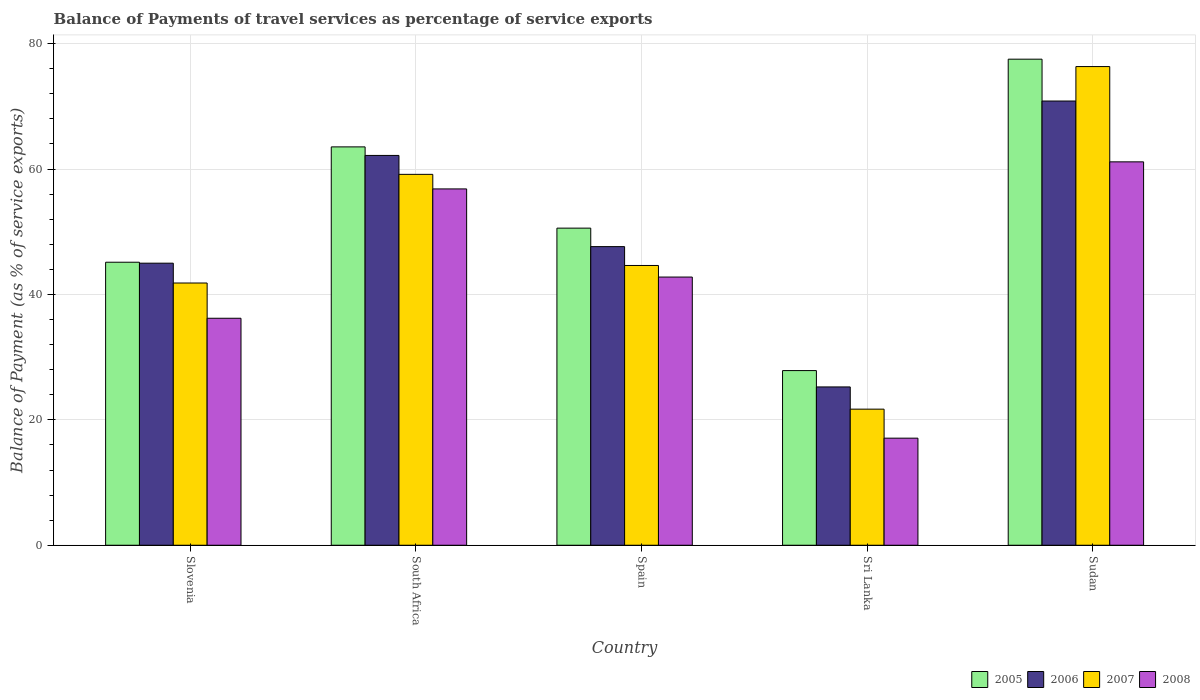How many different coloured bars are there?
Your response must be concise. 4. Are the number of bars per tick equal to the number of legend labels?
Provide a short and direct response. Yes. How many bars are there on the 3rd tick from the right?
Keep it short and to the point. 4. What is the label of the 2nd group of bars from the left?
Your answer should be compact. South Africa. In how many cases, is the number of bars for a given country not equal to the number of legend labels?
Ensure brevity in your answer.  0. What is the balance of payments of travel services in 2006 in South Africa?
Provide a succinct answer. 62.18. Across all countries, what is the maximum balance of payments of travel services in 2006?
Your answer should be very brief. 70.85. Across all countries, what is the minimum balance of payments of travel services in 2007?
Offer a terse response. 21.71. In which country was the balance of payments of travel services in 2005 maximum?
Provide a succinct answer. Sudan. In which country was the balance of payments of travel services in 2007 minimum?
Ensure brevity in your answer.  Sri Lanka. What is the total balance of payments of travel services in 2008 in the graph?
Your response must be concise. 214.05. What is the difference between the balance of payments of travel services in 2005 in South Africa and that in Spain?
Offer a terse response. 12.96. What is the difference between the balance of payments of travel services in 2005 in South Africa and the balance of payments of travel services in 2008 in Sudan?
Offer a very short reply. 2.39. What is the average balance of payments of travel services in 2005 per country?
Your answer should be compact. 52.93. What is the difference between the balance of payments of travel services of/in 2005 and balance of payments of travel services of/in 2007 in Sri Lanka?
Provide a succinct answer. 6.15. In how many countries, is the balance of payments of travel services in 2006 greater than 68 %?
Your answer should be very brief. 1. What is the ratio of the balance of payments of travel services in 2007 in Slovenia to that in Spain?
Your answer should be very brief. 0.94. What is the difference between the highest and the second highest balance of payments of travel services in 2008?
Your response must be concise. 14.06. What is the difference between the highest and the lowest balance of payments of travel services in 2006?
Offer a very short reply. 45.6. What does the 3rd bar from the left in Sudan represents?
Provide a succinct answer. 2007. How many bars are there?
Offer a terse response. 20. How many countries are there in the graph?
Offer a terse response. 5. Are the values on the major ticks of Y-axis written in scientific E-notation?
Give a very brief answer. No. Does the graph contain any zero values?
Give a very brief answer. No. Where does the legend appear in the graph?
Give a very brief answer. Bottom right. What is the title of the graph?
Ensure brevity in your answer.  Balance of Payments of travel services as percentage of service exports. What is the label or title of the X-axis?
Keep it short and to the point. Country. What is the label or title of the Y-axis?
Offer a very short reply. Balance of Payment (as % of service exports). What is the Balance of Payment (as % of service exports) in 2005 in Slovenia?
Offer a very short reply. 45.14. What is the Balance of Payment (as % of service exports) of 2006 in Slovenia?
Provide a short and direct response. 44.99. What is the Balance of Payment (as % of service exports) in 2007 in Slovenia?
Ensure brevity in your answer.  41.83. What is the Balance of Payment (as % of service exports) in 2008 in Slovenia?
Your response must be concise. 36.2. What is the Balance of Payment (as % of service exports) in 2005 in South Africa?
Ensure brevity in your answer.  63.54. What is the Balance of Payment (as % of service exports) in 2006 in South Africa?
Your answer should be very brief. 62.18. What is the Balance of Payment (as % of service exports) in 2007 in South Africa?
Give a very brief answer. 59.16. What is the Balance of Payment (as % of service exports) of 2008 in South Africa?
Give a very brief answer. 56.83. What is the Balance of Payment (as % of service exports) in 2005 in Spain?
Give a very brief answer. 50.58. What is the Balance of Payment (as % of service exports) of 2006 in Spain?
Your response must be concise. 47.63. What is the Balance of Payment (as % of service exports) in 2007 in Spain?
Offer a very short reply. 44.62. What is the Balance of Payment (as % of service exports) of 2008 in Spain?
Make the answer very short. 42.78. What is the Balance of Payment (as % of service exports) of 2005 in Sri Lanka?
Your response must be concise. 27.86. What is the Balance of Payment (as % of service exports) in 2006 in Sri Lanka?
Make the answer very short. 25.25. What is the Balance of Payment (as % of service exports) in 2007 in Sri Lanka?
Provide a short and direct response. 21.71. What is the Balance of Payment (as % of service exports) in 2008 in Sri Lanka?
Provide a short and direct response. 17.08. What is the Balance of Payment (as % of service exports) of 2005 in Sudan?
Your answer should be compact. 77.53. What is the Balance of Payment (as % of service exports) of 2006 in Sudan?
Your answer should be compact. 70.85. What is the Balance of Payment (as % of service exports) in 2007 in Sudan?
Ensure brevity in your answer.  76.35. What is the Balance of Payment (as % of service exports) in 2008 in Sudan?
Give a very brief answer. 61.15. Across all countries, what is the maximum Balance of Payment (as % of service exports) in 2005?
Your response must be concise. 77.53. Across all countries, what is the maximum Balance of Payment (as % of service exports) in 2006?
Provide a succinct answer. 70.85. Across all countries, what is the maximum Balance of Payment (as % of service exports) of 2007?
Ensure brevity in your answer.  76.35. Across all countries, what is the maximum Balance of Payment (as % of service exports) of 2008?
Provide a short and direct response. 61.15. Across all countries, what is the minimum Balance of Payment (as % of service exports) of 2005?
Offer a very short reply. 27.86. Across all countries, what is the minimum Balance of Payment (as % of service exports) in 2006?
Ensure brevity in your answer.  25.25. Across all countries, what is the minimum Balance of Payment (as % of service exports) in 2007?
Give a very brief answer. 21.71. Across all countries, what is the minimum Balance of Payment (as % of service exports) of 2008?
Provide a short and direct response. 17.08. What is the total Balance of Payment (as % of service exports) of 2005 in the graph?
Provide a succinct answer. 264.65. What is the total Balance of Payment (as % of service exports) of 2006 in the graph?
Your response must be concise. 250.9. What is the total Balance of Payment (as % of service exports) in 2007 in the graph?
Offer a very short reply. 243.66. What is the total Balance of Payment (as % of service exports) of 2008 in the graph?
Make the answer very short. 214.05. What is the difference between the Balance of Payment (as % of service exports) in 2005 in Slovenia and that in South Africa?
Your answer should be compact. -18.4. What is the difference between the Balance of Payment (as % of service exports) in 2006 in Slovenia and that in South Africa?
Your response must be concise. -17.19. What is the difference between the Balance of Payment (as % of service exports) of 2007 in Slovenia and that in South Africa?
Your answer should be compact. -17.33. What is the difference between the Balance of Payment (as % of service exports) in 2008 in Slovenia and that in South Africa?
Provide a short and direct response. -20.63. What is the difference between the Balance of Payment (as % of service exports) of 2005 in Slovenia and that in Spain?
Your answer should be compact. -5.44. What is the difference between the Balance of Payment (as % of service exports) of 2006 in Slovenia and that in Spain?
Provide a succinct answer. -2.64. What is the difference between the Balance of Payment (as % of service exports) of 2007 in Slovenia and that in Spain?
Make the answer very short. -2.8. What is the difference between the Balance of Payment (as % of service exports) in 2008 in Slovenia and that in Spain?
Keep it short and to the point. -6.57. What is the difference between the Balance of Payment (as % of service exports) in 2005 in Slovenia and that in Sri Lanka?
Make the answer very short. 17.28. What is the difference between the Balance of Payment (as % of service exports) of 2006 in Slovenia and that in Sri Lanka?
Your answer should be very brief. 19.74. What is the difference between the Balance of Payment (as % of service exports) in 2007 in Slovenia and that in Sri Lanka?
Your answer should be compact. 20.12. What is the difference between the Balance of Payment (as % of service exports) in 2008 in Slovenia and that in Sri Lanka?
Your response must be concise. 19.12. What is the difference between the Balance of Payment (as % of service exports) in 2005 in Slovenia and that in Sudan?
Offer a terse response. -32.39. What is the difference between the Balance of Payment (as % of service exports) in 2006 in Slovenia and that in Sudan?
Your response must be concise. -25.86. What is the difference between the Balance of Payment (as % of service exports) of 2007 in Slovenia and that in Sudan?
Provide a succinct answer. -34.52. What is the difference between the Balance of Payment (as % of service exports) in 2008 in Slovenia and that in Sudan?
Your answer should be very brief. -24.95. What is the difference between the Balance of Payment (as % of service exports) in 2005 in South Africa and that in Spain?
Make the answer very short. 12.96. What is the difference between the Balance of Payment (as % of service exports) of 2006 in South Africa and that in Spain?
Ensure brevity in your answer.  14.55. What is the difference between the Balance of Payment (as % of service exports) in 2007 in South Africa and that in Spain?
Ensure brevity in your answer.  14.53. What is the difference between the Balance of Payment (as % of service exports) in 2008 in South Africa and that in Spain?
Offer a terse response. 14.06. What is the difference between the Balance of Payment (as % of service exports) in 2005 in South Africa and that in Sri Lanka?
Provide a succinct answer. 35.68. What is the difference between the Balance of Payment (as % of service exports) of 2006 in South Africa and that in Sri Lanka?
Your answer should be very brief. 36.93. What is the difference between the Balance of Payment (as % of service exports) in 2007 in South Africa and that in Sri Lanka?
Ensure brevity in your answer.  37.45. What is the difference between the Balance of Payment (as % of service exports) in 2008 in South Africa and that in Sri Lanka?
Offer a terse response. 39.76. What is the difference between the Balance of Payment (as % of service exports) in 2005 in South Africa and that in Sudan?
Your answer should be compact. -13.99. What is the difference between the Balance of Payment (as % of service exports) in 2006 in South Africa and that in Sudan?
Make the answer very short. -8.68. What is the difference between the Balance of Payment (as % of service exports) of 2007 in South Africa and that in Sudan?
Offer a very short reply. -17.19. What is the difference between the Balance of Payment (as % of service exports) in 2008 in South Africa and that in Sudan?
Keep it short and to the point. -4.32. What is the difference between the Balance of Payment (as % of service exports) of 2005 in Spain and that in Sri Lanka?
Provide a short and direct response. 22.72. What is the difference between the Balance of Payment (as % of service exports) in 2006 in Spain and that in Sri Lanka?
Give a very brief answer. 22.38. What is the difference between the Balance of Payment (as % of service exports) in 2007 in Spain and that in Sri Lanka?
Make the answer very short. 22.92. What is the difference between the Balance of Payment (as % of service exports) in 2008 in Spain and that in Sri Lanka?
Your answer should be compact. 25.7. What is the difference between the Balance of Payment (as % of service exports) of 2005 in Spain and that in Sudan?
Your answer should be very brief. -26.95. What is the difference between the Balance of Payment (as % of service exports) of 2006 in Spain and that in Sudan?
Offer a very short reply. -23.22. What is the difference between the Balance of Payment (as % of service exports) in 2007 in Spain and that in Sudan?
Your response must be concise. -31.73. What is the difference between the Balance of Payment (as % of service exports) in 2008 in Spain and that in Sudan?
Provide a short and direct response. -18.38. What is the difference between the Balance of Payment (as % of service exports) in 2005 in Sri Lanka and that in Sudan?
Provide a succinct answer. -49.67. What is the difference between the Balance of Payment (as % of service exports) of 2006 in Sri Lanka and that in Sudan?
Give a very brief answer. -45.6. What is the difference between the Balance of Payment (as % of service exports) of 2007 in Sri Lanka and that in Sudan?
Ensure brevity in your answer.  -54.64. What is the difference between the Balance of Payment (as % of service exports) in 2008 in Sri Lanka and that in Sudan?
Your response must be concise. -44.07. What is the difference between the Balance of Payment (as % of service exports) in 2005 in Slovenia and the Balance of Payment (as % of service exports) in 2006 in South Africa?
Provide a short and direct response. -17.04. What is the difference between the Balance of Payment (as % of service exports) in 2005 in Slovenia and the Balance of Payment (as % of service exports) in 2007 in South Africa?
Provide a short and direct response. -14.02. What is the difference between the Balance of Payment (as % of service exports) of 2005 in Slovenia and the Balance of Payment (as % of service exports) of 2008 in South Africa?
Provide a short and direct response. -11.69. What is the difference between the Balance of Payment (as % of service exports) of 2006 in Slovenia and the Balance of Payment (as % of service exports) of 2007 in South Africa?
Give a very brief answer. -14.17. What is the difference between the Balance of Payment (as % of service exports) of 2006 in Slovenia and the Balance of Payment (as % of service exports) of 2008 in South Africa?
Provide a succinct answer. -11.84. What is the difference between the Balance of Payment (as % of service exports) of 2007 in Slovenia and the Balance of Payment (as % of service exports) of 2008 in South Africa?
Your response must be concise. -15.01. What is the difference between the Balance of Payment (as % of service exports) in 2005 in Slovenia and the Balance of Payment (as % of service exports) in 2006 in Spain?
Your answer should be very brief. -2.49. What is the difference between the Balance of Payment (as % of service exports) of 2005 in Slovenia and the Balance of Payment (as % of service exports) of 2007 in Spain?
Offer a very short reply. 0.52. What is the difference between the Balance of Payment (as % of service exports) of 2005 in Slovenia and the Balance of Payment (as % of service exports) of 2008 in Spain?
Provide a succinct answer. 2.37. What is the difference between the Balance of Payment (as % of service exports) of 2006 in Slovenia and the Balance of Payment (as % of service exports) of 2007 in Spain?
Offer a terse response. 0.37. What is the difference between the Balance of Payment (as % of service exports) of 2006 in Slovenia and the Balance of Payment (as % of service exports) of 2008 in Spain?
Provide a short and direct response. 2.21. What is the difference between the Balance of Payment (as % of service exports) in 2007 in Slovenia and the Balance of Payment (as % of service exports) in 2008 in Spain?
Keep it short and to the point. -0.95. What is the difference between the Balance of Payment (as % of service exports) of 2005 in Slovenia and the Balance of Payment (as % of service exports) of 2006 in Sri Lanka?
Provide a short and direct response. 19.89. What is the difference between the Balance of Payment (as % of service exports) of 2005 in Slovenia and the Balance of Payment (as % of service exports) of 2007 in Sri Lanka?
Give a very brief answer. 23.43. What is the difference between the Balance of Payment (as % of service exports) in 2005 in Slovenia and the Balance of Payment (as % of service exports) in 2008 in Sri Lanka?
Keep it short and to the point. 28.06. What is the difference between the Balance of Payment (as % of service exports) of 2006 in Slovenia and the Balance of Payment (as % of service exports) of 2007 in Sri Lanka?
Keep it short and to the point. 23.28. What is the difference between the Balance of Payment (as % of service exports) of 2006 in Slovenia and the Balance of Payment (as % of service exports) of 2008 in Sri Lanka?
Offer a very short reply. 27.91. What is the difference between the Balance of Payment (as % of service exports) in 2007 in Slovenia and the Balance of Payment (as % of service exports) in 2008 in Sri Lanka?
Your answer should be very brief. 24.75. What is the difference between the Balance of Payment (as % of service exports) in 2005 in Slovenia and the Balance of Payment (as % of service exports) in 2006 in Sudan?
Give a very brief answer. -25.71. What is the difference between the Balance of Payment (as % of service exports) of 2005 in Slovenia and the Balance of Payment (as % of service exports) of 2007 in Sudan?
Your answer should be very brief. -31.21. What is the difference between the Balance of Payment (as % of service exports) of 2005 in Slovenia and the Balance of Payment (as % of service exports) of 2008 in Sudan?
Make the answer very short. -16.01. What is the difference between the Balance of Payment (as % of service exports) in 2006 in Slovenia and the Balance of Payment (as % of service exports) in 2007 in Sudan?
Your response must be concise. -31.36. What is the difference between the Balance of Payment (as % of service exports) of 2006 in Slovenia and the Balance of Payment (as % of service exports) of 2008 in Sudan?
Provide a short and direct response. -16.16. What is the difference between the Balance of Payment (as % of service exports) of 2007 in Slovenia and the Balance of Payment (as % of service exports) of 2008 in Sudan?
Offer a very short reply. -19.33. What is the difference between the Balance of Payment (as % of service exports) of 2005 in South Africa and the Balance of Payment (as % of service exports) of 2006 in Spain?
Offer a terse response. 15.91. What is the difference between the Balance of Payment (as % of service exports) of 2005 in South Africa and the Balance of Payment (as % of service exports) of 2007 in Spain?
Ensure brevity in your answer.  18.92. What is the difference between the Balance of Payment (as % of service exports) of 2005 in South Africa and the Balance of Payment (as % of service exports) of 2008 in Spain?
Your response must be concise. 20.76. What is the difference between the Balance of Payment (as % of service exports) in 2006 in South Africa and the Balance of Payment (as % of service exports) in 2007 in Spain?
Ensure brevity in your answer.  17.55. What is the difference between the Balance of Payment (as % of service exports) of 2006 in South Africa and the Balance of Payment (as % of service exports) of 2008 in Spain?
Provide a succinct answer. 19.4. What is the difference between the Balance of Payment (as % of service exports) of 2007 in South Africa and the Balance of Payment (as % of service exports) of 2008 in Spain?
Offer a very short reply. 16.38. What is the difference between the Balance of Payment (as % of service exports) in 2005 in South Africa and the Balance of Payment (as % of service exports) in 2006 in Sri Lanka?
Offer a terse response. 38.29. What is the difference between the Balance of Payment (as % of service exports) of 2005 in South Africa and the Balance of Payment (as % of service exports) of 2007 in Sri Lanka?
Ensure brevity in your answer.  41.83. What is the difference between the Balance of Payment (as % of service exports) in 2005 in South Africa and the Balance of Payment (as % of service exports) in 2008 in Sri Lanka?
Offer a very short reply. 46.46. What is the difference between the Balance of Payment (as % of service exports) in 2006 in South Africa and the Balance of Payment (as % of service exports) in 2007 in Sri Lanka?
Offer a terse response. 40.47. What is the difference between the Balance of Payment (as % of service exports) of 2006 in South Africa and the Balance of Payment (as % of service exports) of 2008 in Sri Lanka?
Give a very brief answer. 45.1. What is the difference between the Balance of Payment (as % of service exports) in 2007 in South Africa and the Balance of Payment (as % of service exports) in 2008 in Sri Lanka?
Ensure brevity in your answer.  42.08. What is the difference between the Balance of Payment (as % of service exports) in 2005 in South Africa and the Balance of Payment (as % of service exports) in 2006 in Sudan?
Provide a succinct answer. -7.31. What is the difference between the Balance of Payment (as % of service exports) of 2005 in South Africa and the Balance of Payment (as % of service exports) of 2007 in Sudan?
Provide a succinct answer. -12.81. What is the difference between the Balance of Payment (as % of service exports) of 2005 in South Africa and the Balance of Payment (as % of service exports) of 2008 in Sudan?
Provide a short and direct response. 2.39. What is the difference between the Balance of Payment (as % of service exports) in 2006 in South Africa and the Balance of Payment (as % of service exports) in 2007 in Sudan?
Make the answer very short. -14.17. What is the difference between the Balance of Payment (as % of service exports) of 2006 in South Africa and the Balance of Payment (as % of service exports) of 2008 in Sudan?
Provide a short and direct response. 1.02. What is the difference between the Balance of Payment (as % of service exports) of 2007 in South Africa and the Balance of Payment (as % of service exports) of 2008 in Sudan?
Your answer should be compact. -2. What is the difference between the Balance of Payment (as % of service exports) of 2005 in Spain and the Balance of Payment (as % of service exports) of 2006 in Sri Lanka?
Your answer should be compact. 25.33. What is the difference between the Balance of Payment (as % of service exports) in 2005 in Spain and the Balance of Payment (as % of service exports) in 2007 in Sri Lanka?
Make the answer very short. 28.87. What is the difference between the Balance of Payment (as % of service exports) of 2005 in Spain and the Balance of Payment (as % of service exports) of 2008 in Sri Lanka?
Offer a very short reply. 33.5. What is the difference between the Balance of Payment (as % of service exports) in 2006 in Spain and the Balance of Payment (as % of service exports) in 2007 in Sri Lanka?
Your answer should be compact. 25.92. What is the difference between the Balance of Payment (as % of service exports) of 2006 in Spain and the Balance of Payment (as % of service exports) of 2008 in Sri Lanka?
Your answer should be very brief. 30.55. What is the difference between the Balance of Payment (as % of service exports) in 2007 in Spain and the Balance of Payment (as % of service exports) in 2008 in Sri Lanka?
Give a very brief answer. 27.54. What is the difference between the Balance of Payment (as % of service exports) of 2005 in Spain and the Balance of Payment (as % of service exports) of 2006 in Sudan?
Provide a succinct answer. -20.28. What is the difference between the Balance of Payment (as % of service exports) of 2005 in Spain and the Balance of Payment (as % of service exports) of 2007 in Sudan?
Offer a terse response. -25.77. What is the difference between the Balance of Payment (as % of service exports) in 2005 in Spain and the Balance of Payment (as % of service exports) in 2008 in Sudan?
Offer a very short reply. -10.57. What is the difference between the Balance of Payment (as % of service exports) of 2006 in Spain and the Balance of Payment (as % of service exports) of 2007 in Sudan?
Give a very brief answer. -28.72. What is the difference between the Balance of Payment (as % of service exports) of 2006 in Spain and the Balance of Payment (as % of service exports) of 2008 in Sudan?
Offer a very short reply. -13.52. What is the difference between the Balance of Payment (as % of service exports) of 2007 in Spain and the Balance of Payment (as % of service exports) of 2008 in Sudan?
Provide a short and direct response. -16.53. What is the difference between the Balance of Payment (as % of service exports) of 2005 in Sri Lanka and the Balance of Payment (as % of service exports) of 2006 in Sudan?
Your answer should be compact. -43. What is the difference between the Balance of Payment (as % of service exports) of 2005 in Sri Lanka and the Balance of Payment (as % of service exports) of 2007 in Sudan?
Provide a succinct answer. -48.49. What is the difference between the Balance of Payment (as % of service exports) of 2005 in Sri Lanka and the Balance of Payment (as % of service exports) of 2008 in Sudan?
Keep it short and to the point. -33.29. What is the difference between the Balance of Payment (as % of service exports) in 2006 in Sri Lanka and the Balance of Payment (as % of service exports) in 2007 in Sudan?
Offer a very short reply. -51.1. What is the difference between the Balance of Payment (as % of service exports) of 2006 in Sri Lanka and the Balance of Payment (as % of service exports) of 2008 in Sudan?
Keep it short and to the point. -35.9. What is the difference between the Balance of Payment (as % of service exports) of 2007 in Sri Lanka and the Balance of Payment (as % of service exports) of 2008 in Sudan?
Your answer should be very brief. -39.45. What is the average Balance of Payment (as % of service exports) in 2005 per country?
Make the answer very short. 52.93. What is the average Balance of Payment (as % of service exports) in 2006 per country?
Ensure brevity in your answer.  50.18. What is the average Balance of Payment (as % of service exports) of 2007 per country?
Offer a very short reply. 48.73. What is the average Balance of Payment (as % of service exports) of 2008 per country?
Offer a terse response. 42.81. What is the difference between the Balance of Payment (as % of service exports) of 2005 and Balance of Payment (as % of service exports) of 2006 in Slovenia?
Ensure brevity in your answer.  0.15. What is the difference between the Balance of Payment (as % of service exports) of 2005 and Balance of Payment (as % of service exports) of 2007 in Slovenia?
Offer a terse response. 3.31. What is the difference between the Balance of Payment (as % of service exports) in 2005 and Balance of Payment (as % of service exports) in 2008 in Slovenia?
Provide a short and direct response. 8.94. What is the difference between the Balance of Payment (as % of service exports) in 2006 and Balance of Payment (as % of service exports) in 2007 in Slovenia?
Offer a terse response. 3.16. What is the difference between the Balance of Payment (as % of service exports) of 2006 and Balance of Payment (as % of service exports) of 2008 in Slovenia?
Make the answer very short. 8.79. What is the difference between the Balance of Payment (as % of service exports) in 2007 and Balance of Payment (as % of service exports) in 2008 in Slovenia?
Offer a terse response. 5.62. What is the difference between the Balance of Payment (as % of service exports) in 2005 and Balance of Payment (as % of service exports) in 2006 in South Africa?
Ensure brevity in your answer.  1.36. What is the difference between the Balance of Payment (as % of service exports) of 2005 and Balance of Payment (as % of service exports) of 2007 in South Africa?
Ensure brevity in your answer.  4.38. What is the difference between the Balance of Payment (as % of service exports) in 2005 and Balance of Payment (as % of service exports) in 2008 in South Africa?
Your response must be concise. 6.71. What is the difference between the Balance of Payment (as % of service exports) in 2006 and Balance of Payment (as % of service exports) in 2007 in South Africa?
Ensure brevity in your answer.  3.02. What is the difference between the Balance of Payment (as % of service exports) of 2006 and Balance of Payment (as % of service exports) of 2008 in South Africa?
Make the answer very short. 5.34. What is the difference between the Balance of Payment (as % of service exports) of 2007 and Balance of Payment (as % of service exports) of 2008 in South Africa?
Ensure brevity in your answer.  2.32. What is the difference between the Balance of Payment (as % of service exports) in 2005 and Balance of Payment (as % of service exports) in 2006 in Spain?
Your answer should be very brief. 2.95. What is the difference between the Balance of Payment (as % of service exports) of 2005 and Balance of Payment (as % of service exports) of 2007 in Spain?
Offer a terse response. 5.96. What is the difference between the Balance of Payment (as % of service exports) in 2005 and Balance of Payment (as % of service exports) in 2008 in Spain?
Make the answer very short. 7.8. What is the difference between the Balance of Payment (as % of service exports) of 2006 and Balance of Payment (as % of service exports) of 2007 in Spain?
Provide a succinct answer. 3.01. What is the difference between the Balance of Payment (as % of service exports) in 2006 and Balance of Payment (as % of service exports) in 2008 in Spain?
Offer a terse response. 4.86. What is the difference between the Balance of Payment (as % of service exports) of 2007 and Balance of Payment (as % of service exports) of 2008 in Spain?
Make the answer very short. 1.85. What is the difference between the Balance of Payment (as % of service exports) in 2005 and Balance of Payment (as % of service exports) in 2006 in Sri Lanka?
Offer a very short reply. 2.61. What is the difference between the Balance of Payment (as % of service exports) of 2005 and Balance of Payment (as % of service exports) of 2007 in Sri Lanka?
Provide a short and direct response. 6.15. What is the difference between the Balance of Payment (as % of service exports) in 2005 and Balance of Payment (as % of service exports) in 2008 in Sri Lanka?
Your response must be concise. 10.78. What is the difference between the Balance of Payment (as % of service exports) of 2006 and Balance of Payment (as % of service exports) of 2007 in Sri Lanka?
Keep it short and to the point. 3.54. What is the difference between the Balance of Payment (as % of service exports) in 2006 and Balance of Payment (as % of service exports) in 2008 in Sri Lanka?
Offer a terse response. 8.17. What is the difference between the Balance of Payment (as % of service exports) in 2007 and Balance of Payment (as % of service exports) in 2008 in Sri Lanka?
Offer a terse response. 4.63. What is the difference between the Balance of Payment (as % of service exports) in 2005 and Balance of Payment (as % of service exports) in 2006 in Sudan?
Provide a short and direct response. 6.67. What is the difference between the Balance of Payment (as % of service exports) of 2005 and Balance of Payment (as % of service exports) of 2007 in Sudan?
Provide a short and direct response. 1.18. What is the difference between the Balance of Payment (as % of service exports) of 2005 and Balance of Payment (as % of service exports) of 2008 in Sudan?
Provide a short and direct response. 16.38. What is the difference between the Balance of Payment (as % of service exports) of 2006 and Balance of Payment (as % of service exports) of 2007 in Sudan?
Provide a succinct answer. -5.5. What is the difference between the Balance of Payment (as % of service exports) of 2006 and Balance of Payment (as % of service exports) of 2008 in Sudan?
Ensure brevity in your answer.  9.7. What is the difference between the Balance of Payment (as % of service exports) in 2007 and Balance of Payment (as % of service exports) in 2008 in Sudan?
Offer a terse response. 15.2. What is the ratio of the Balance of Payment (as % of service exports) in 2005 in Slovenia to that in South Africa?
Provide a short and direct response. 0.71. What is the ratio of the Balance of Payment (as % of service exports) of 2006 in Slovenia to that in South Africa?
Provide a short and direct response. 0.72. What is the ratio of the Balance of Payment (as % of service exports) in 2007 in Slovenia to that in South Africa?
Offer a very short reply. 0.71. What is the ratio of the Balance of Payment (as % of service exports) of 2008 in Slovenia to that in South Africa?
Offer a very short reply. 0.64. What is the ratio of the Balance of Payment (as % of service exports) of 2005 in Slovenia to that in Spain?
Your response must be concise. 0.89. What is the ratio of the Balance of Payment (as % of service exports) of 2006 in Slovenia to that in Spain?
Your answer should be very brief. 0.94. What is the ratio of the Balance of Payment (as % of service exports) in 2007 in Slovenia to that in Spain?
Offer a very short reply. 0.94. What is the ratio of the Balance of Payment (as % of service exports) of 2008 in Slovenia to that in Spain?
Keep it short and to the point. 0.85. What is the ratio of the Balance of Payment (as % of service exports) in 2005 in Slovenia to that in Sri Lanka?
Offer a terse response. 1.62. What is the ratio of the Balance of Payment (as % of service exports) in 2006 in Slovenia to that in Sri Lanka?
Keep it short and to the point. 1.78. What is the ratio of the Balance of Payment (as % of service exports) of 2007 in Slovenia to that in Sri Lanka?
Provide a succinct answer. 1.93. What is the ratio of the Balance of Payment (as % of service exports) in 2008 in Slovenia to that in Sri Lanka?
Your answer should be compact. 2.12. What is the ratio of the Balance of Payment (as % of service exports) in 2005 in Slovenia to that in Sudan?
Your answer should be compact. 0.58. What is the ratio of the Balance of Payment (as % of service exports) of 2006 in Slovenia to that in Sudan?
Offer a very short reply. 0.64. What is the ratio of the Balance of Payment (as % of service exports) in 2007 in Slovenia to that in Sudan?
Keep it short and to the point. 0.55. What is the ratio of the Balance of Payment (as % of service exports) of 2008 in Slovenia to that in Sudan?
Your response must be concise. 0.59. What is the ratio of the Balance of Payment (as % of service exports) in 2005 in South Africa to that in Spain?
Keep it short and to the point. 1.26. What is the ratio of the Balance of Payment (as % of service exports) in 2006 in South Africa to that in Spain?
Offer a terse response. 1.31. What is the ratio of the Balance of Payment (as % of service exports) of 2007 in South Africa to that in Spain?
Ensure brevity in your answer.  1.33. What is the ratio of the Balance of Payment (as % of service exports) in 2008 in South Africa to that in Spain?
Your response must be concise. 1.33. What is the ratio of the Balance of Payment (as % of service exports) in 2005 in South Africa to that in Sri Lanka?
Ensure brevity in your answer.  2.28. What is the ratio of the Balance of Payment (as % of service exports) in 2006 in South Africa to that in Sri Lanka?
Your response must be concise. 2.46. What is the ratio of the Balance of Payment (as % of service exports) of 2007 in South Africa to that in Sri Lanka?
Ensure brevity in your answer.  2.73. What is the ratio of the Balance of Payment (as % of service exports) of 2008 in South Africa to that in Sri Lanka?
Offer a terse response. 3.33. What is the ratio of the Balance of Payment (as % of service exports) of 2005 in South Africa to that in Sudan?
Give a very brief answer. 0.82. What is the ratio of the Balance of Payment (as % of service exports) in 2006 in South Africa to that in Sudan?
Keep it short and to the point. 0.88. What is the ratio of the Balance of Payment (as % of service exports) in 2007 in South Africa to that in Sudan?
Ensure brevity in your answer.  0.77. What is the ratio of the Balance of Payment (as % of service exports) of 2008 in South Africa to that in Sudan?
Give a very brief answer. 0.93. What is the ratio of the Balance of Payment (as % of service exports) in 2005 in Spain to that in Sri Lanka?
Ensure brevity in your answer.  1.82. What is the ratio of the Balance of Payment (as % of service exports) in 2006 in Spain to that in Sri Lanka?
Give a very brief answer. 1.89. What is the ratio of the Balance of Payment (as % of service exports) of 2007 in Spain to that in Sri Lanka?
Offer a very short reply. 2.06. What is the ratio of the Balance of Payment (as % of service exports) in 2008 in Spain to that in Sri Lanka?
Give a very brief answer. 2.5. What is the ratio of the Balance of Payment (as % of service exports) in 2005 in Spain to that in Sudan?
Provide a succinct answer. 0.65. What is the ratio of the Balance of Payment (as % of service exports) of 2006 in Spain to that in Sudan?
Your answer should be compact. 0.67. What is the ratio of the Balance of Payment (as % of service exports) of 2007 in Spain to that in Sudan?
Give a very brief answer. 0.58. What is the ratio of the Balance of Payment (as % of service exports) of 2008 in Spain to that in Sudan?
Make the answer very short. 0.7. What is the ratio of the Balance of Payment (as % of service exports) in 2005 in Sri Lanka to that in Sudan?
Offer a very short reply. 0.36. What is the ratio of the Balance of Payment (as % of service exports) in 2006 in Sri Lanka to that in Sudan?
Ensure brevity in your answer.  0.36. What is the ratio of the Balance of Payment (as % of service exports) in 2007 in Sri Lanka to that in Sudan?
Offer a terse response. 0.28. What is the ratio of the Balance of Payment (as % of service exports) of 2008 in Sri Lanka to that in Sudan?
Your answer should be very brief. 0.28. What is the difference between the highest and the second highest Balance of Payment (as % of service exports) in 2005?
Offer a very short reply. 13.99. What is the difference between the highest and the second highest Balance of Payment (as % of service exports) in 2006?
Offer a very short reply. 8.68. What is the difference between the highest and the second highest Balance of Payment (as % of service exports) in 2007?
Offer a very short reply. 17.19. What is the difference between the highest and the second highest Balance of Payment (as % of service exports) of 2008?
Your response must be concise. 4.32. What is the difference between the highest and the lowest Balance of Payment (as % of service exports) in 2005?
Offer a very short reply. 49.67. What is the difference between the highest and the lowest Balance of Payment (as % of service exports) of 2006?
Your answer should be compact. 45.6. What is the difference between the highest and the lowest Balance of Payment (as % of service exports) in 2007?
Your response must be concise. 54.64. What is the difference between the highest and the lowest Balance of Payment (as % of service exports) in 2008?
Your answer should be compact. 44.07. 